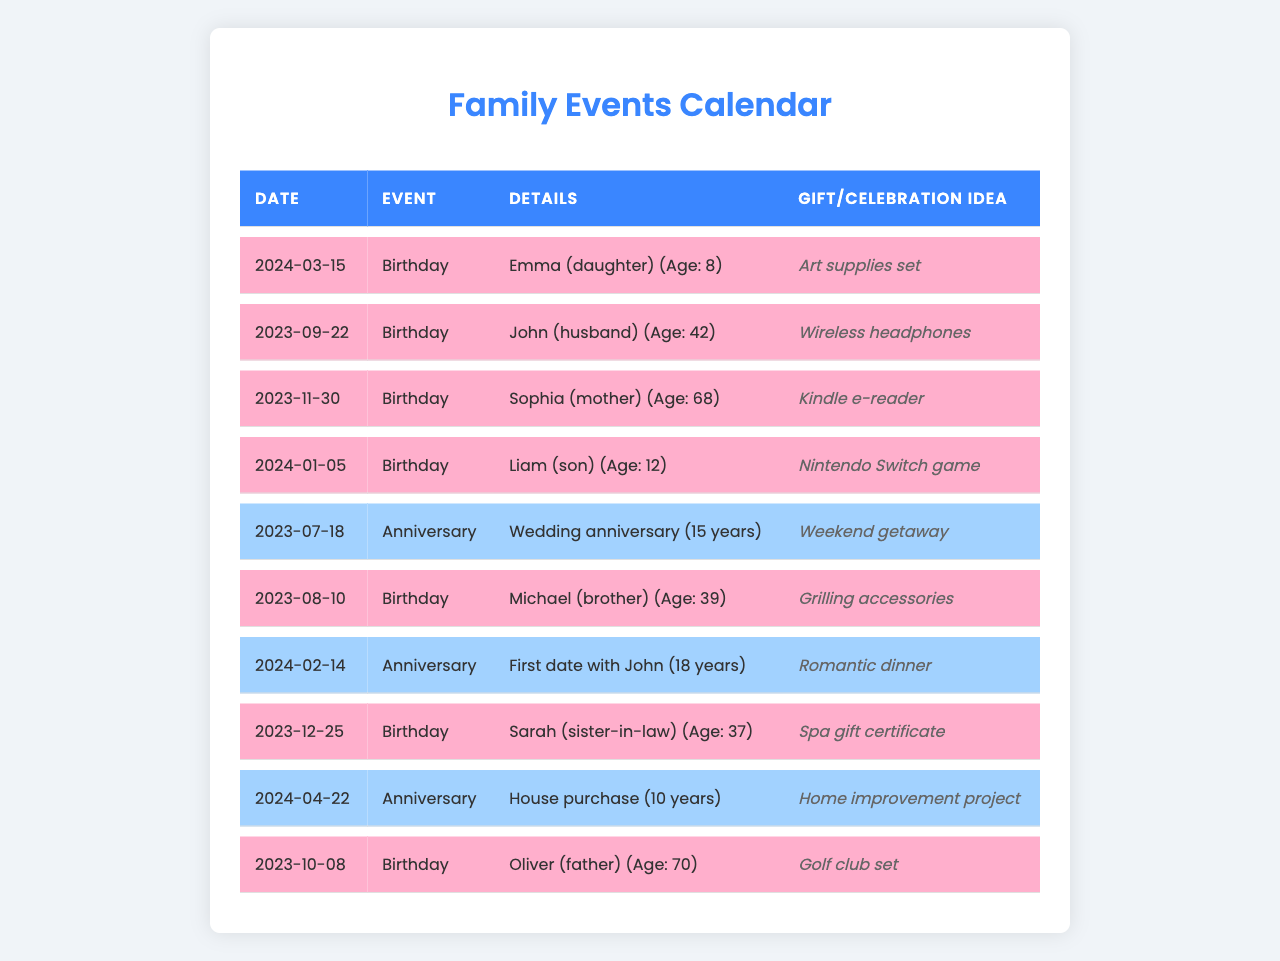What's the birthday of Emma? The table lists Emma's birthday on March 15, 2024.
Answer: March 15, 2024 How old will Liam be on his birthday? The table shows that Liam's age is 12, which means he will be 13 on January 5, 2024.
Answer: 13 Is Michael's birthday before John's? Michael's birthday is on August 10, 2023, while John's birthday is on September 22, 2023. Since August comes before September, the answer is yes.
Answer: Yes What is the gift idea for Oliver's birthday? The table states that the gift idea for Oliver's birthday is a golf club set.
Answer: Golf club set How many anniversaries are listed in total? There are four events labeled as anniversaries in the table.
Answer: 4 When did John and the person referred to as "mother" celebrate their wedding anniversary? The wedding anniversary is celebrated on July 18, 2023, while "mother" (Sophia) has a birthday on November 30, 2023.
Answer: July 18, 2023 What is the average age of family members celebrating birthdays this year? The ages listed for the birthdays in 2023 are 42 (John), 68 (Sophia), 39 (Michael), 70 (Oliver), and 8 (Emma), totaling 227 years. Divided by the 5 members gives an average of 45.4.
Answer: 45.4 What birthday is closest to today's date? Since today is October 2023, the closest upcoming birthday is Liam's on January 5, 2024.
Answer: January 5, 2024 Is there any event celebrated for more than 15 years? The table shows the wedding anniversary celebrated for 15 years and the first date with John for 18 years, confirming the presence of events over 15 years.
Answer: Yes Which family member will be the oldest at the next birthday celebration? Oliver is currently 70 years old, making him the oldest at his birthday on October 8, 2023.
Answer: Oliver 